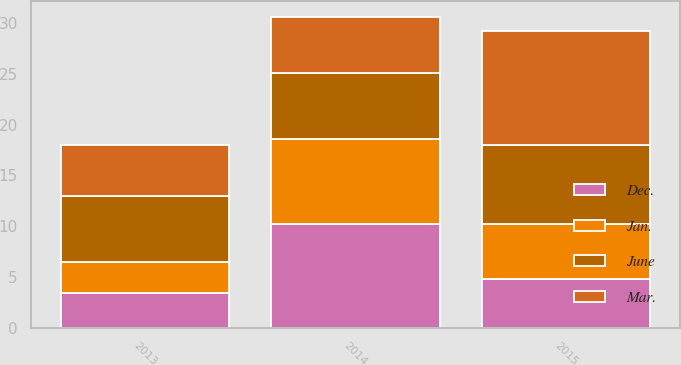<chart> <loc_0><loc_0><loc_500><loc_500><stacked_bar_chart><ecel><fcel>2015<fcel>2014<fcel>2013<nl><fcel>Mar.<fcel>11.2<fcel>5.5<fcel>5<nl><fcel>June<fcel>7.8<fcel>6.5<fcel>6.5<nl><fcel>Dec.<fcel>4.8<fcel>10.2<fcel>3.4<nl><fcel>Jan.<fcel>5.4<fcel>8.4<fcel>3.1<nl></chart> 